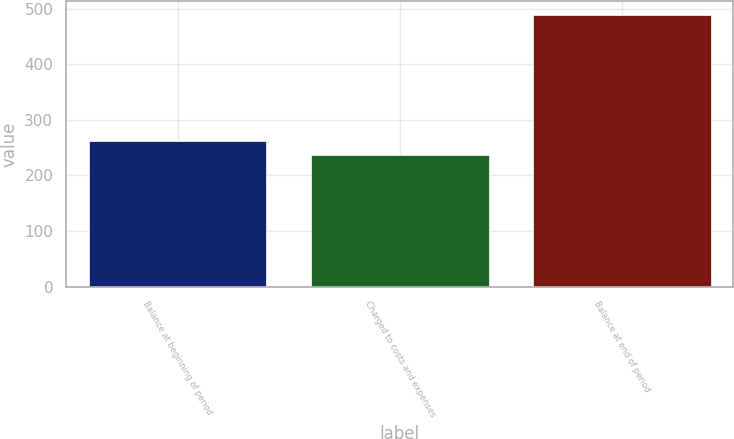<chart> <loc_0><loc_0><loc_500><loc_500><bar_chart><fcel>Balance at beginning of period<fcel>Charged to costs and expenses<fcel>Balance at end of period<nl><fcel>261.26<fcel>236<fcel>488.6<nl></chart> 